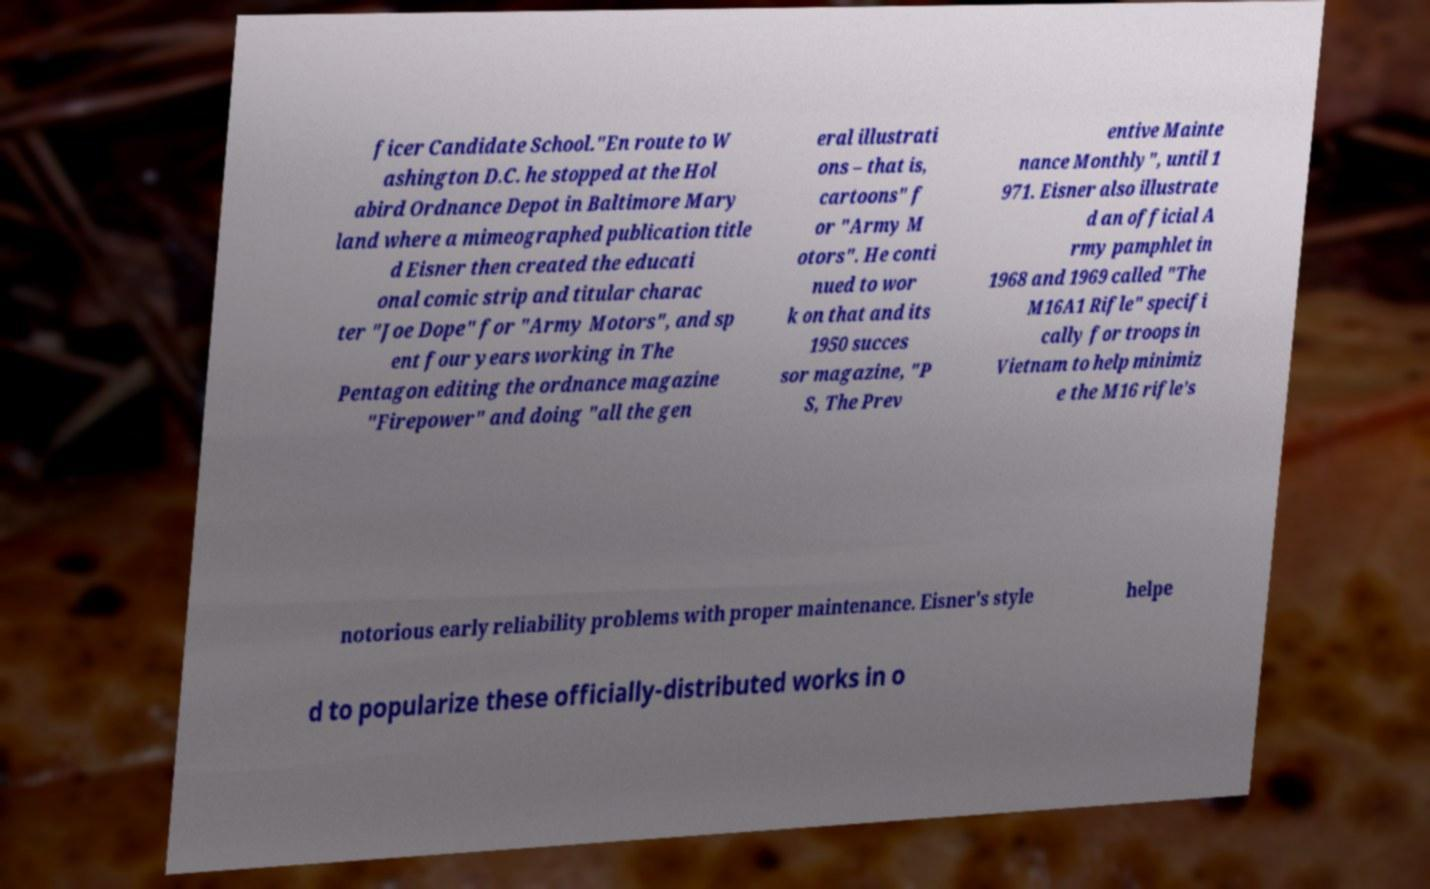For documentation purposes, I need the text within this image transcribed. Could you provide that? ficer Candidate School."En route to W ashington D.C. he stopped at the Hol abird Ordnance Depot in Baltimore Mary land where a mimeographed publication title d Eisner then created the educati onal comic strip and titular charac ter "Joe Dope" for "Army Motors", and sp ent four years working in The Pentagon editing the ordnance magazine "Firepower" and doing "all the gen eral illustrati ons – that is, cartoons" f or "Army M otors". He conti nued to wor k on that and its 1950 succes sor magazine, "P S, The Prev entive Mainte nance Monthly", until 1 971. Eisner also illustrate d an official A rmy pamphlet in 1968 and 1969 called "The M16A1 Rifle" specifi cally for troops in Vietnam to help minimiz e the M16 rifle's notorious early reliability problems with proper maintenance. Eisner's style helpe d to popularize these officially-distributed works in o 